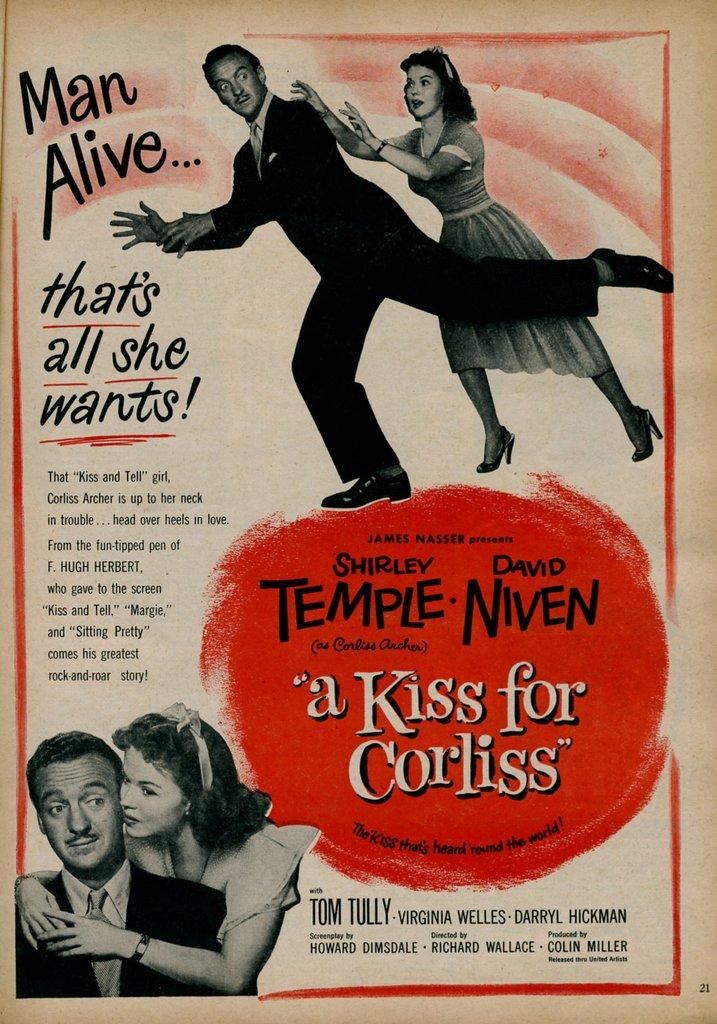Who is a kiss for?
Your answer should be compact. Corliss. What actress is listed in the red spot?
Offer a terse response. Shirley temple. 